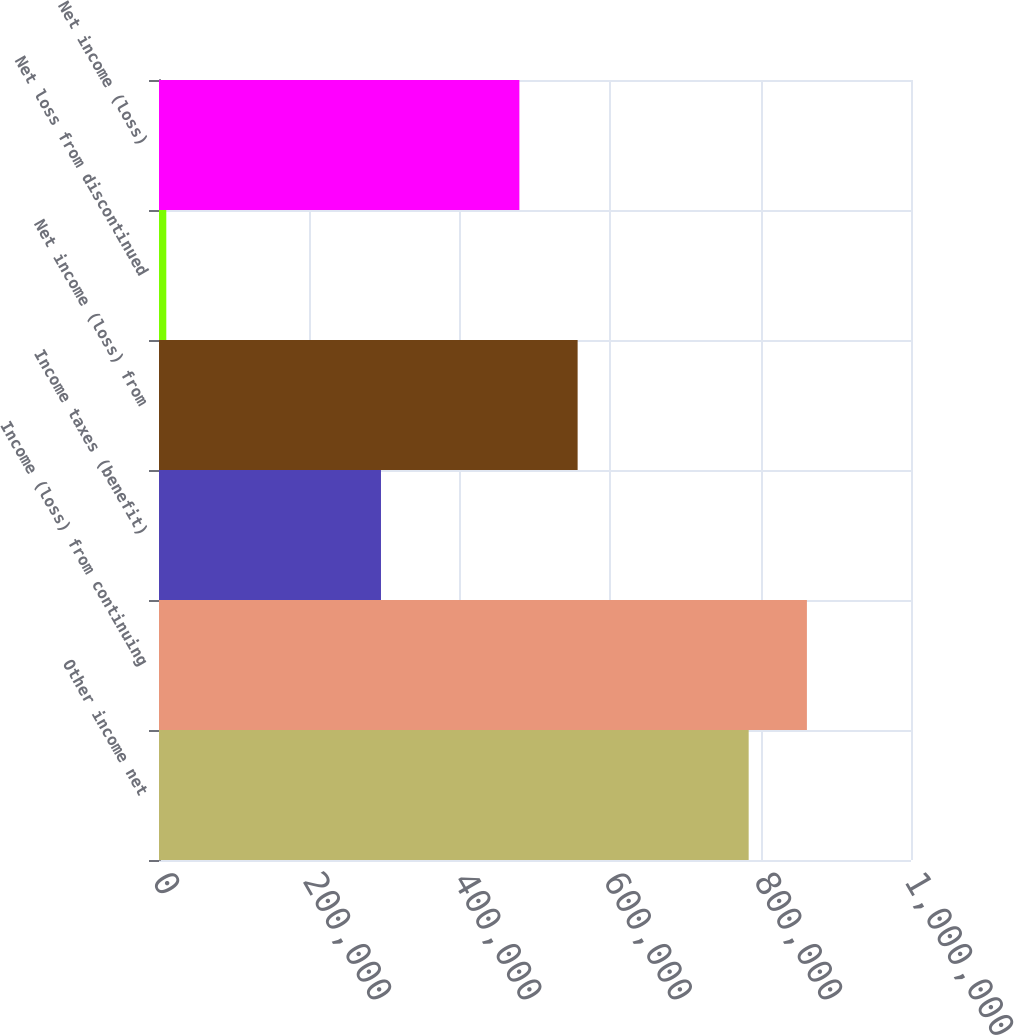Convert chart to OTSL. <chart><loc_0><loc_0><loc_500><loc_500><bar_chart><fcel>Other income net<fcel>Income (loss) from continuing<fcel>Income taxes (benefit)<fcel>Net income (loss) from<fcel>Net loss from discontinued<fcel>Net income (loss)<nl><fcel>784135<fcel>861578<fcel>295189<fcel>556685<fcel>9704<fcel>479242<nl></chart> 